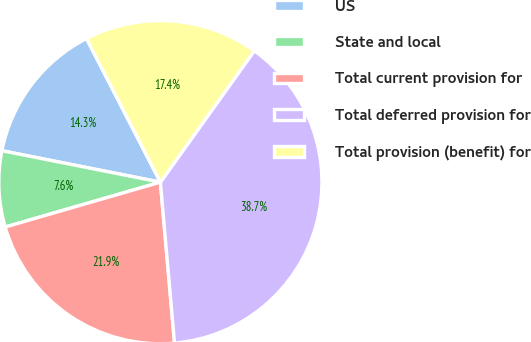<chart> <loc_0><loc_0><loc_500><loc_500><pie_chart><fcel>US<fcel>State and local<fcel>Total current provision for<fcel>Total deferred provision for<fcel>Total provision (benefit) for<nl><fcel>14.32%<fcel>7.6%<fcel>21.92%<fcel>38.73%<fcel>17.44%<nl></chart> 